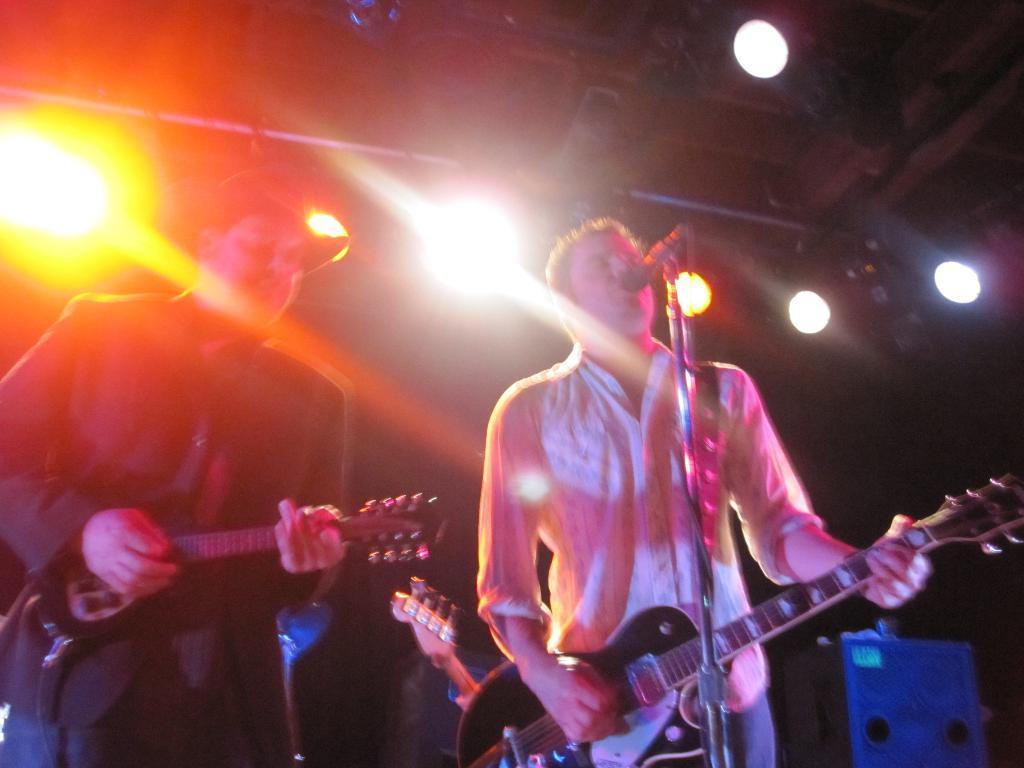Please provide a concise description of this image. This is floor these two persons standing and holding guitar. There is a microphone with stand. On the background we can see lights. This person wear cap. 